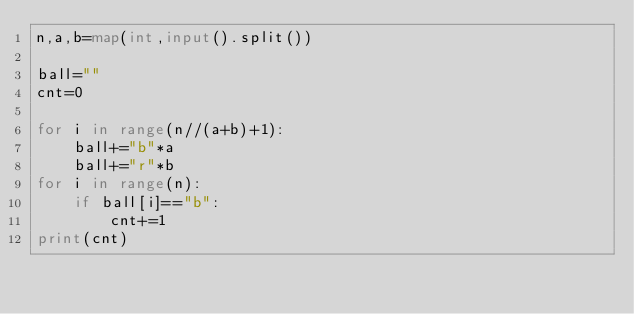<code> <loc_0><loc_0><loc_500><loc_500><_Python_>n,a,b=map(int,input().split())

ball=""
cnt=0

for i in range(n//(a+b)+1):
    ball+="b"*a
    ball+="r"*b
for i in range(n):
    if ball[i]=="b":
        cnt+=1
print(cnt)</code> 